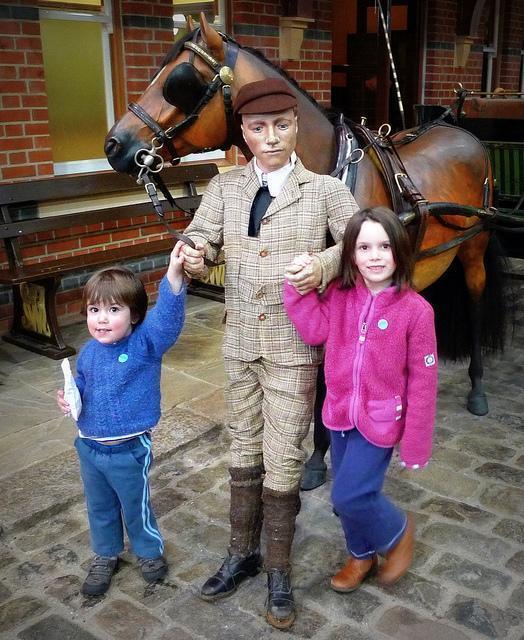How many people are there?
Give a very brief answer. 3. How many trucks do you see?
Give a very brief answer. 0. 